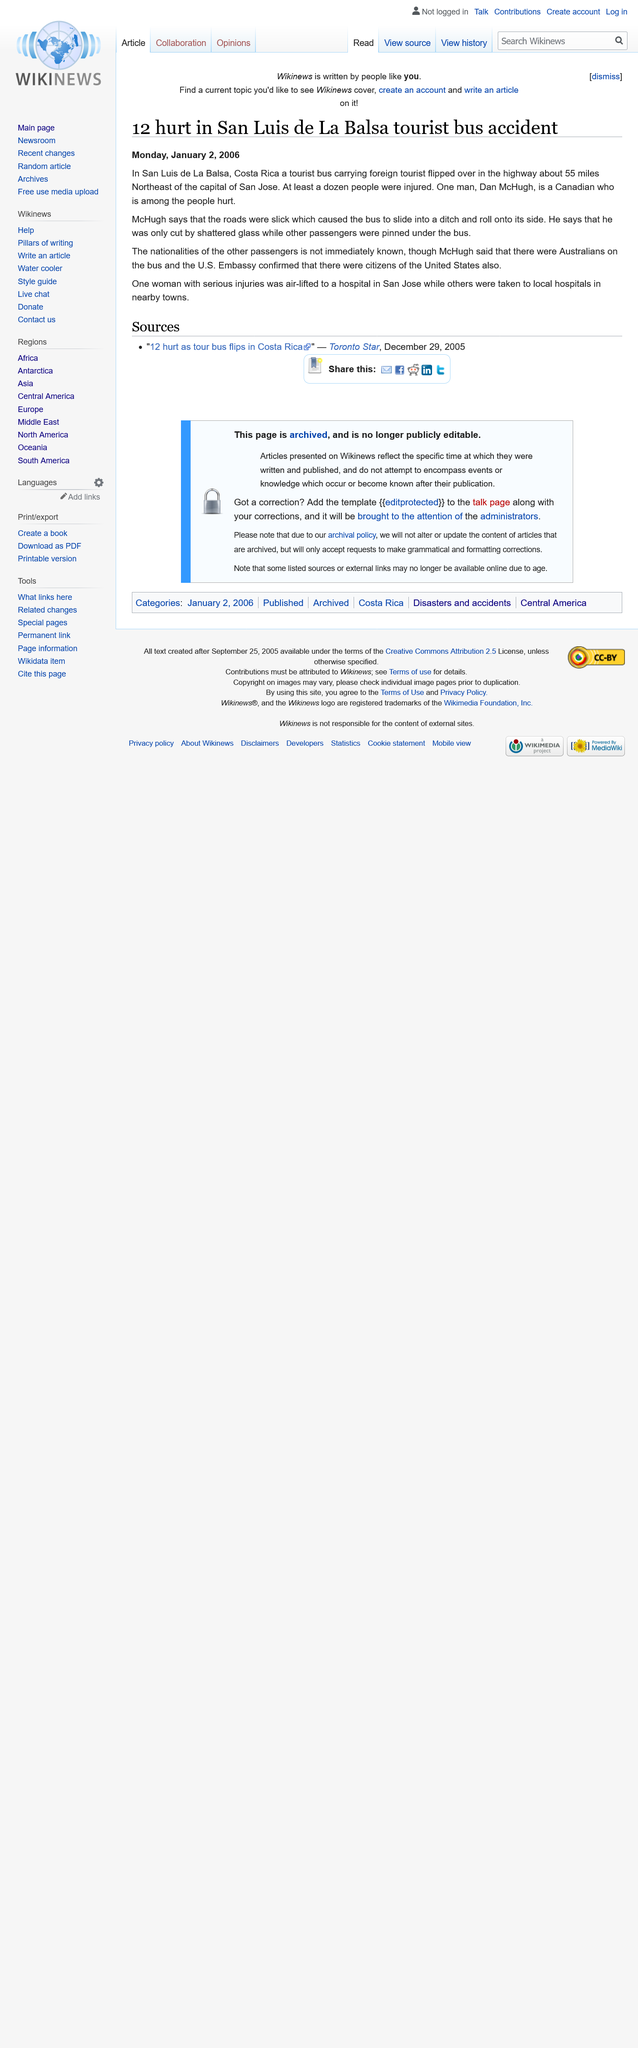Give some essential details in this illustration. The article titled "12 hurt in San Luis de La Balsa tourist bus accident" was published on January 2, 2006. San Luis de La Balsa is located in Costa Rica. The capital of Costa Rica is San Jose, a city known for its vibrant culture and natural beauty. 